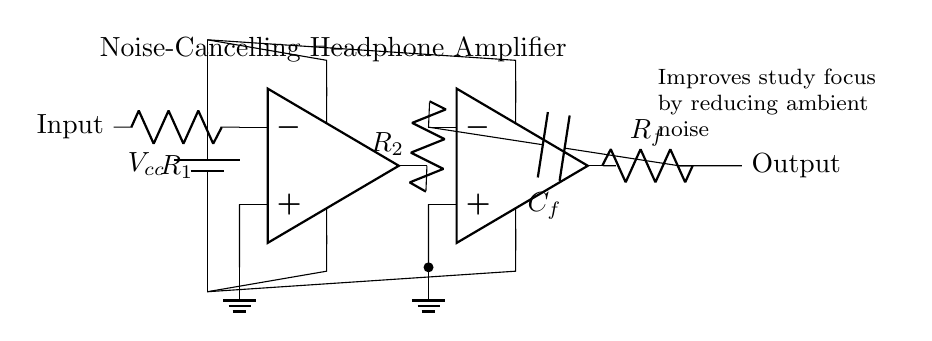what type of amplifier is depicted in the circuit? The circuit diagram shows an operational amplifier configuration used specifically as a noise-cancelling headphone amplifier, indicated by the use of op-amps and the labels throughout the diagram.
Answer: operational amplifier what is the purpose of resistor R1? R1 is connected to the inverting input of the first op-amp, serving to process the incoming audio signal; it sets the gain and the input impedance for the amplifier.
Answer: input impedance how many operational amplifiers are in the circuit? There are two operational amplifiers present in the circuit, as indicated by the two op-amp symbols shown in the diagram.
Answer: two what is the function of the feedback capacitor Cf? The capacitor Cf provides stability and controls the frequency response within the feedback loop of the second op-amp, which is crucial for maintaining audio quality and eliminating unwanted noise.
Answer: stability and frequency control which component reduces ambient noise? The configuration of the two operational amplifiers together with the circuitry, including feedback, helps to actively cancel out ambient noise from external sources.
Answer: operational amplifiers how does the amplifier improve study focus? By minimizing environmental sounds, the amplifier allows the user to concentrate better on their studies by providing clearer audio without distractions, as shown in the description in the diagram.
Answer: reduces ambient noise 